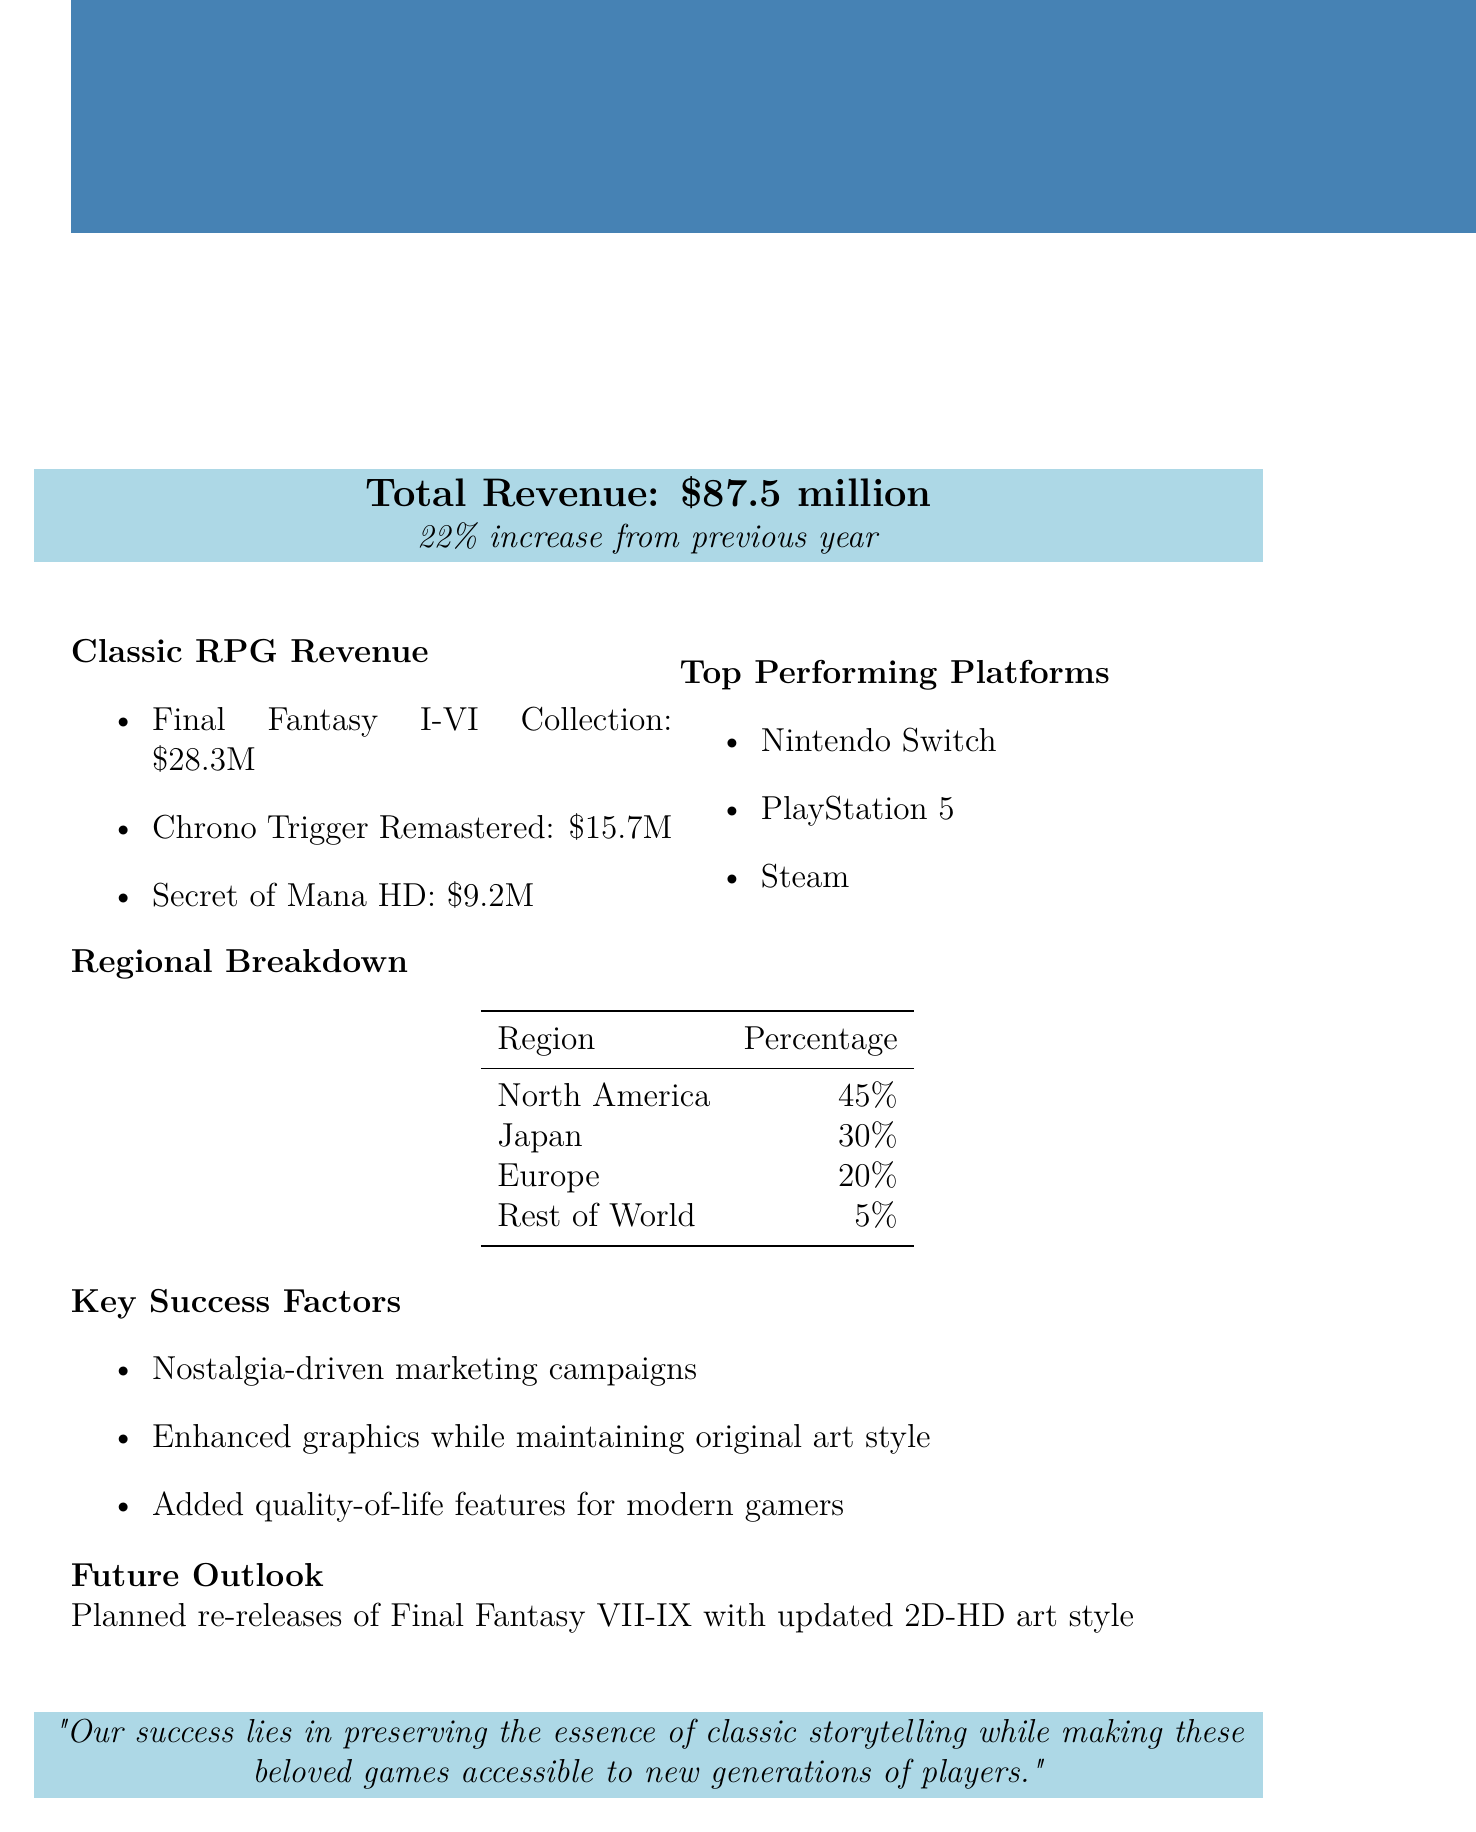What is the total revenue? The total revenue is explicitly mentioned in the document as $87.5 million.
Answer: $87.5 million What is the revenue from Final Fantasy I-VI Collection? The document lists the revenue earned from this specific collection as $28.3 million.
Answer: $28.3 million What percentage of revenue comes from Japan? The document states that Japan accounts for 30% of the revenue.
Answer: 30% What are the top performing platforms? The report lists three top performing platforms: Nintendo Switch, PlayStation 5, and Steam.
Answer: Nintendo Switch, PlayStation 5, Steam What was the percentage increase in revenue from the previous year? The document indicates that there was a 22% increase from the previous year.
Answer: 22% What marketing strategy is mentioned as a key success factor? The report highlights "Nostalgia-driven marketing campaigns" as one of the key factors for success.
Answer: Nostalgia-driven marketing campaigns What future projects are mentioned in the outlook? The document refers to planned re-releases of Final Fantasy VII-IX with updated art.
Answer: Final Fantasy VII-IX What is the revenue from Chrono Trigger Remastered? The document states the revenue from Chrono Trigger Remastered as $15.7 million.
Answer: $15.7 million What is the essence of the studio's success according to the quote? The quote emphasizes the importance of preserving classic storytelling while making games accessible.
Answer: Preserving the essence of classic storytelling 